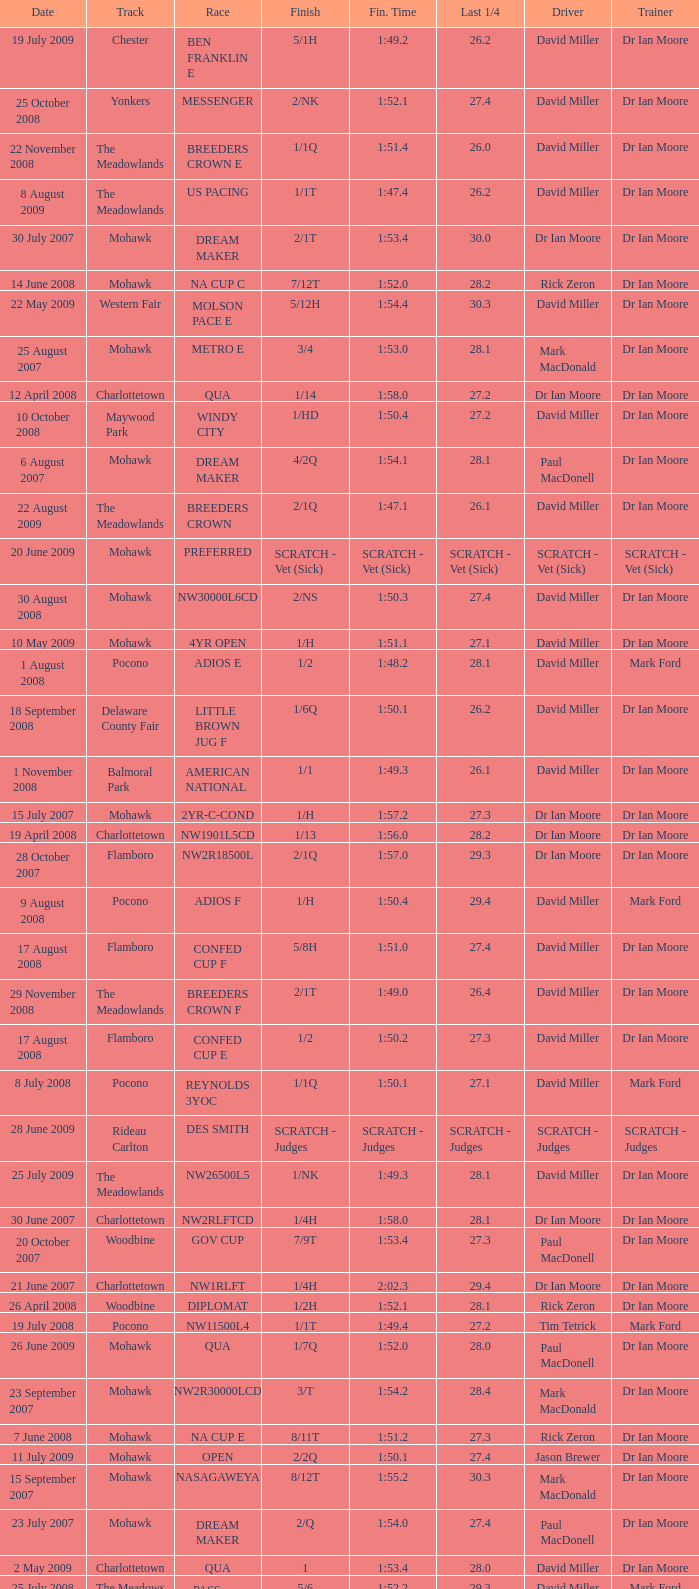What is the finishing time with a 2/1q finish on the Meadowlands track? 1:47.1. 